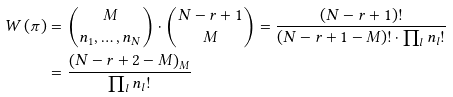<formula> <loc_0><loc_0><loc_500><loc_500>W \left ( \pi \right ) & = \binom { M } { n _ { 1 } , \dots , n _ { N } } \cdot \binom { N - r + 1 } { M } = \frac { ( N - r + 1 ) ! } { ( N - r + 1 - M ) ! \cdot \prod _ { l } n _ { l } ! } \\ & = \frac { \left ( N - r + 2 - M \right ) _ { M } } { \prod _ { l } n _ { l } ! }</formula> 